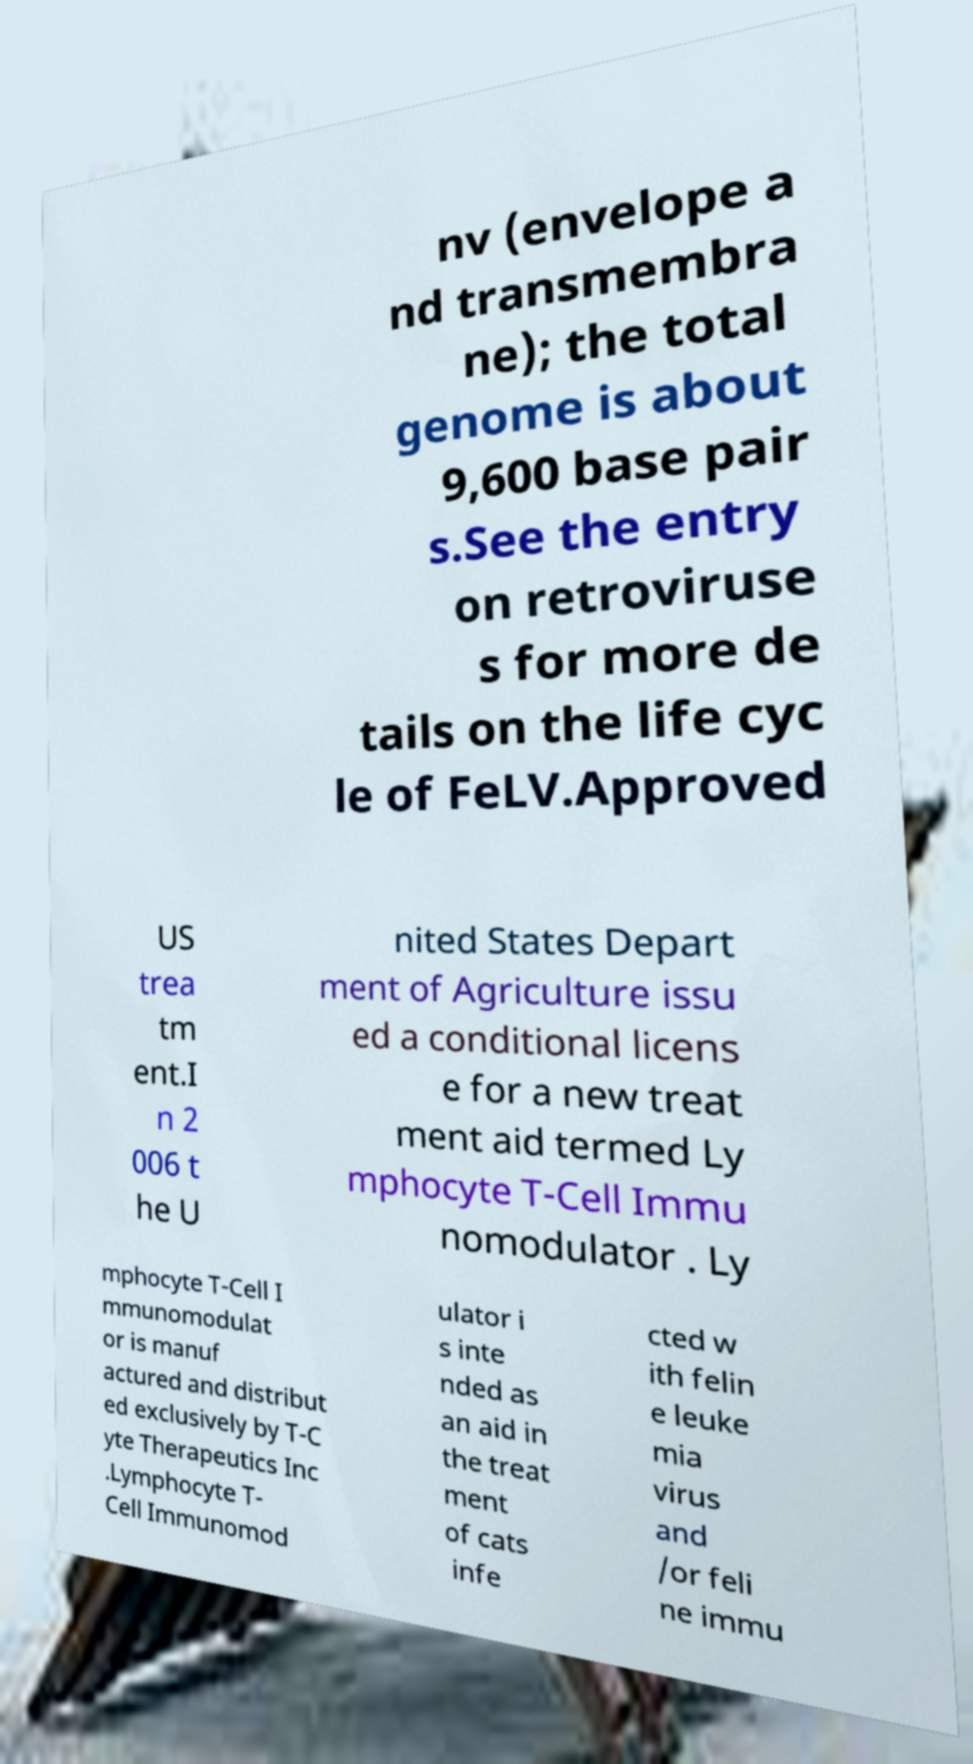Can you accurately transcribe the text from the provided image for me? nv (envelope a nd transmembra ne); the total genome is about 9,600 base pair s.See the entry on retroviruse s for more de tails on the life cyc le of FeLV.Approved US trea tm ent.I n 2 006 t he U nited States Depart ment of Agriculture issu ed a conditional licens e for a new treat ment aid termed Ly mphocyte T-Cell Immu nomodulator . Ly mphocyte T-Cell I mmunomodulat or is manuf actured and distribut ed exclusively by T-C yte Therapeutics Inc .Lymphocyte T- Cell Immunomod ulator i s inte nded as an aid in the treat ment of cats infe cted w ith felin e leuke mia virus and /or feli ne immu 